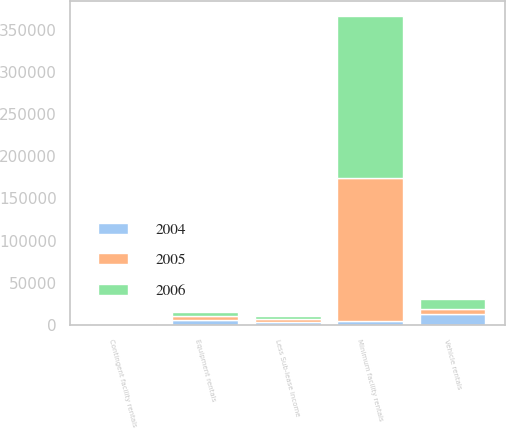Convert chart. <chart><loc_0><loc_0><loc_500><loc_500><stacked_bar_chart><ecel><fcel>Minimum facility rentals<fcel>Contingent facility rentals<fcel>Equipment rentals<fcel>Vehicle rentals<fcel>Less Sub-lease income<nl><fcel>2004<fcel>4647<fcel>1090<fcel>5735<fcel>13554<fcel>4166<nl><fcel>2006<fcel>191897<fcel>1334<fcel>4128<fcel>11316<fcel>3665<nl><fcel>2005<fcel>169449<fcel>1201<fcel>5128<fcel>6007<fcel>3171<nl></chart> 